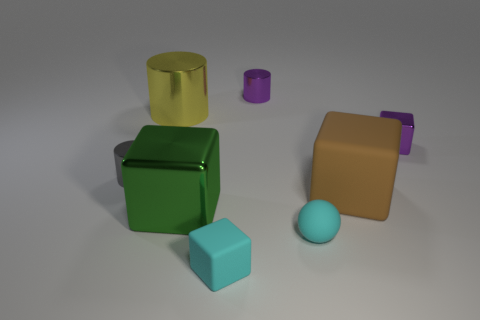Add 2 big brown matte things. How many objects exist? 10 Subtract all cylinders. How many objects are left? 5 Add 6 big blocks. How many big blocks are left? 8 Add 1 tiny green metal spheres. How many tiny green metal spheres exist? 1 Subtract 0 yellow spheres. How many objects are left? 8 Subtract all cyan spheres. Subtract all big yellow shiny cylinders. How many objects are left? 6 